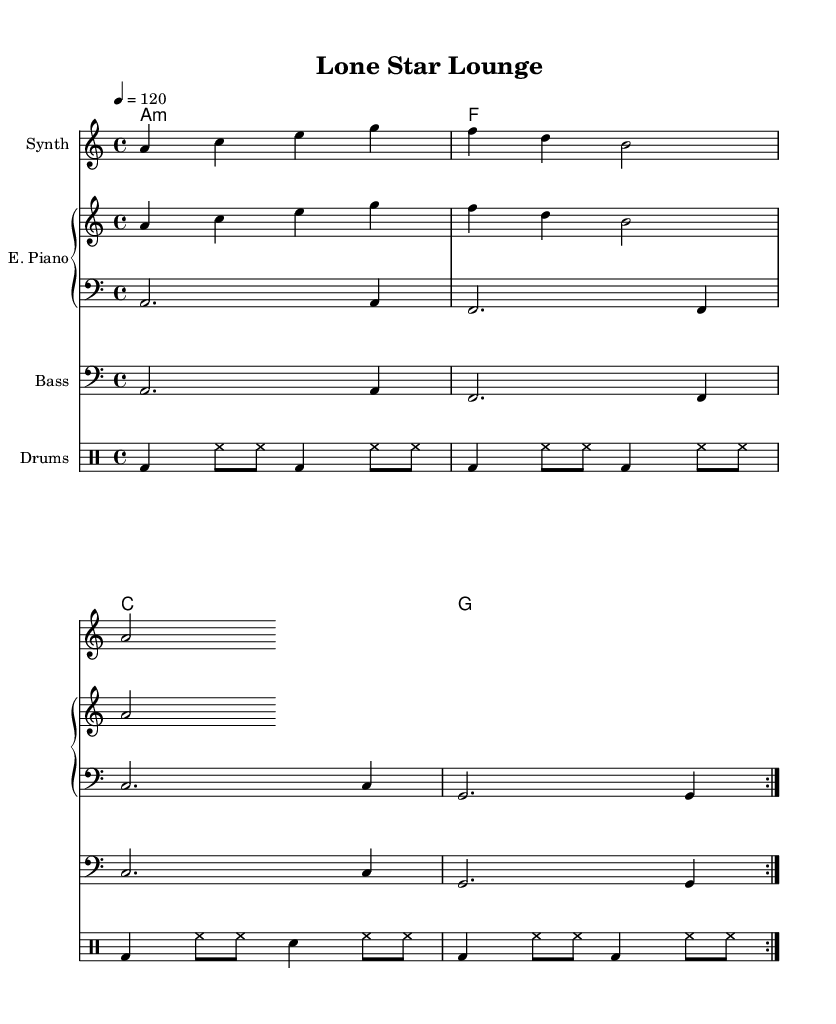What is the key signature of this music? The key signature is A minor, indicated by the absence of sharps or flats on the staff. A minor is the relative minor of C major.
Answer: A minor What is the time signature of this music? The time signature is 4/4, as indicated at the beginning of the score. This means there are four beats in each measure and the quarter note gets one beat.
Answer: 4/4 What is the tempo marking for this piece? The tempo marking is 120, which is indicated by the tempo marking "4 = 120." This means the quarter note should be played at 120 beats per minute.
Answer: 120 What instruments are used in this score? The score features a synth, electric piano, bass, and drums. Each instrument is clearly labeled in the respective staves within the score.
Answer: Synth, E. Piano, Bass, Drums How many bars are contained in the drum part repeat section? The drum part repeats a total of 8 bars, indicated by the repeat volta and the structure of the rhythm in the notated part. Each section of the repeat contains 4 bars.
Answer: 8 What chord progression is used in the harmony section? The chord progression consists of A minor, F major, C major, and G major. These chords are represented in the chord names section of the score.
Answer: A minor, F, C, G Which style of music does this piece represent? This piece represents Deep House music as indicated by the chill sound and the structure that aligns with characteristics typical of the genre. This style often includes smooth melodies and steady rhythms.
Answer: Chill Deep House 